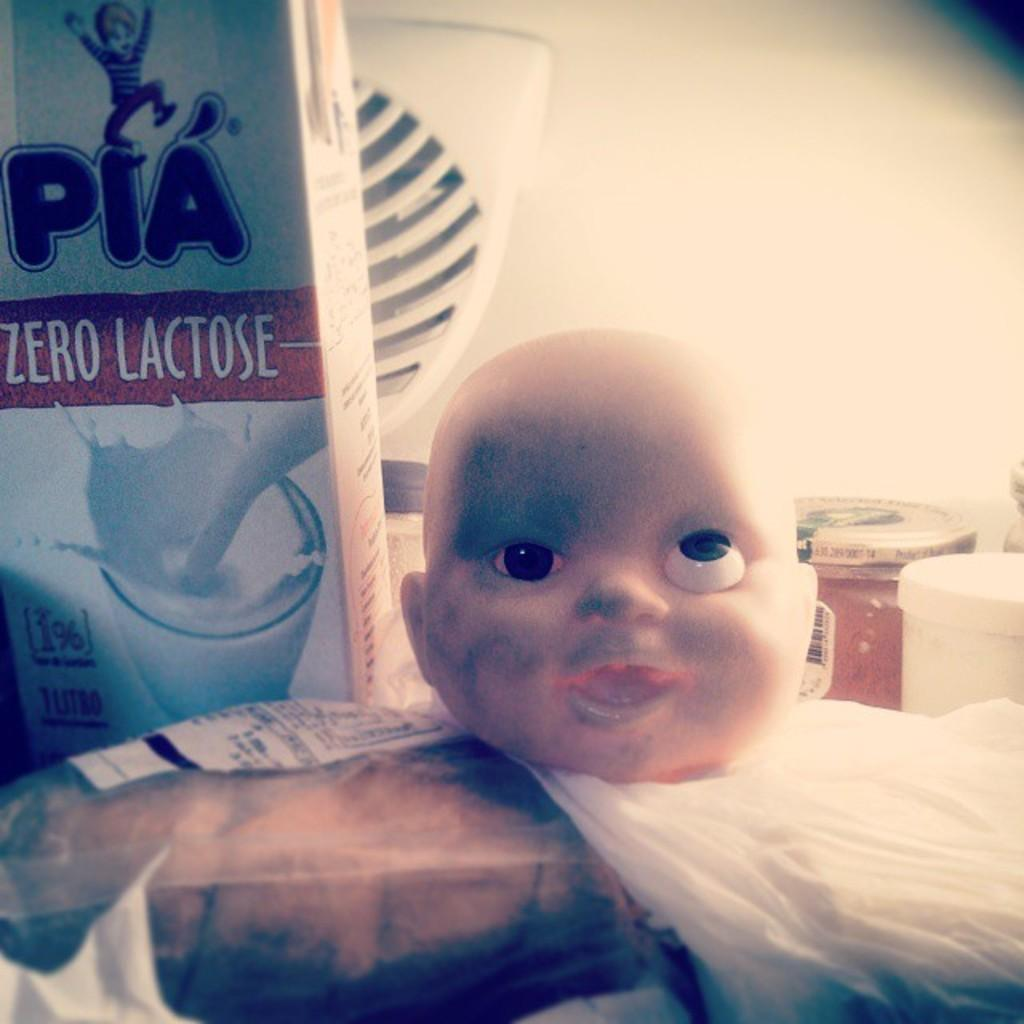What is the main subject of the image? The main subject of the image is a doll face. What is covering the doll face in the image? There are covers in the image. What object is present in the image that could be used for storage? There is a box in the image. What can be seen behind the doll face in the image? There are jars visible behind the doll face. What is the tendency of the cast in the field in the image? There is no cast or field present in the image; it features a doll face with covers, a box, and jars. 